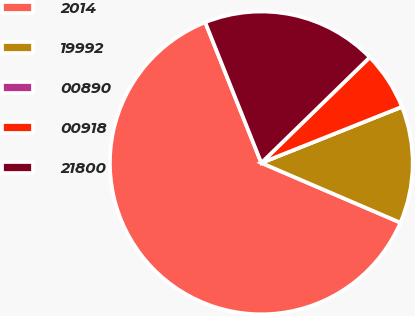Convert chart to OTSL. <chart><loc_0><loc_0><loc_500><loc_500><pie_chart><fcel>2014<fcel>19992<fcel>00890<fcel>00918<fcel>21800<nl><fcel>62.5%<fcel>12.5%<fcel>0.0%<fcel>6.25%<fcel>18.75%<nl></chart> 